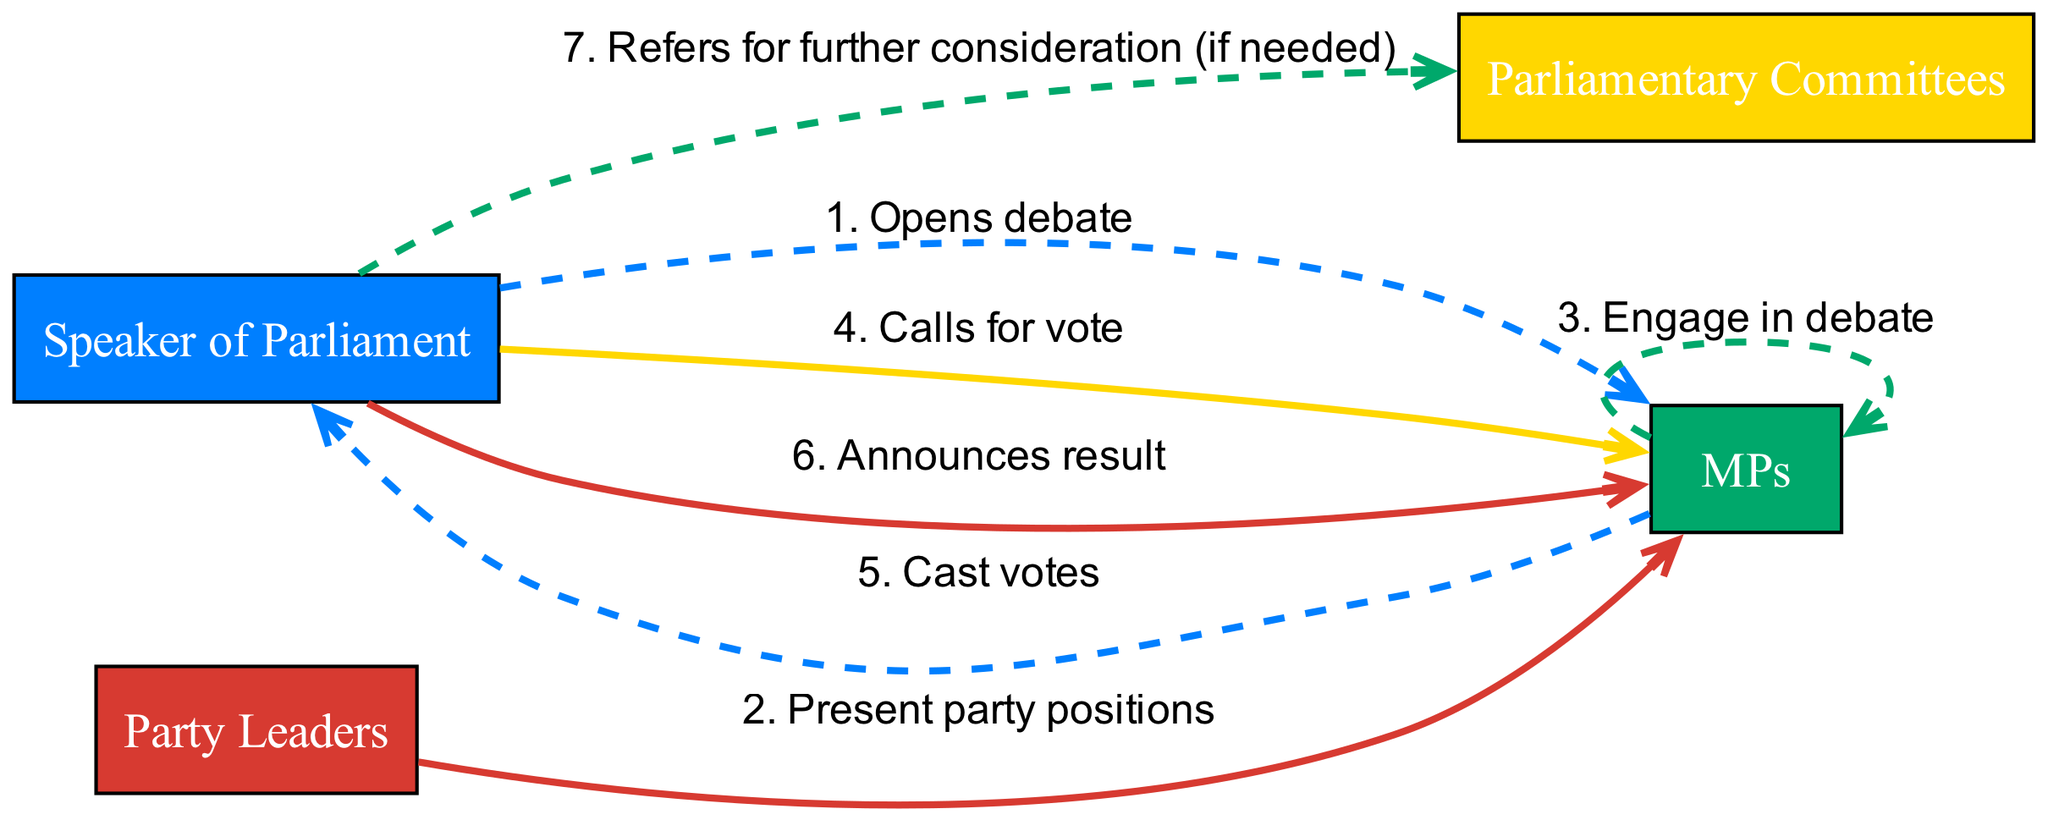What actor opens the debate? The diagram indicates that the Speaker of Parliament is the actor responsible for opening the debate as shown in the first sequence step.
Answer: Speaker of Parliament How many actors are involved in the sequence? The diagram lists four distinct actors: Speaker of Parliament, Party Leaders, MPs, and Parliamentary Committees. Thus, the total number of actors involved is four.
Answer: 4 What action follows the engagement in debate? According to the sequence, after MPs engage in debate, the next action is the Speaker of Parliament calling for a vote, which is specified in the fourth sequence step.
Answer: Calls for vote Which actor announces the result? The diagram explicitly shows that the Speaker of Parliament announces the result after the votes have been cast, as indicated in the sixth sequence step.
Answer: Speaker of Parliament What action is taken if further consideration is needed? The last action in the sequence specifies that the Speaker of Parliament refers the matter to Parliamentary Committees for further consideration if necessary, indicating a procedural protocol in the debate.
Answer: Refers for further consideration What is the order of the first three actions in the diagram? The first three actions are: Opening the debate by the Speaker of Parliament, Party Leaders presenting their positions, and MPs engaging in debate, as outlined in the first three sequence steps.
Answer: Opens debate, Present party positions, Engage in debate How many times do the MPs cast votes? The diagram specifies that MPs cast votes only once, which occurs in the fifth step of the sequence following the call for a vote.
Answer: Once Which two actors are connected by the action "Cast votes"? The diagram shows the connection of the MPs casting votes directed to the Speaker of Parliament, as indicated in the fifth sequence step.
Answer: MPs and Speaker of Parliament What style is used for the edge connecting "Calls for vote" to "Cast votes"? The edge style connecting the action of calling for a vote to the action of casting votes is defined as solid, based on the alternating style employed in the sequence diagram.
Answer: Solid 